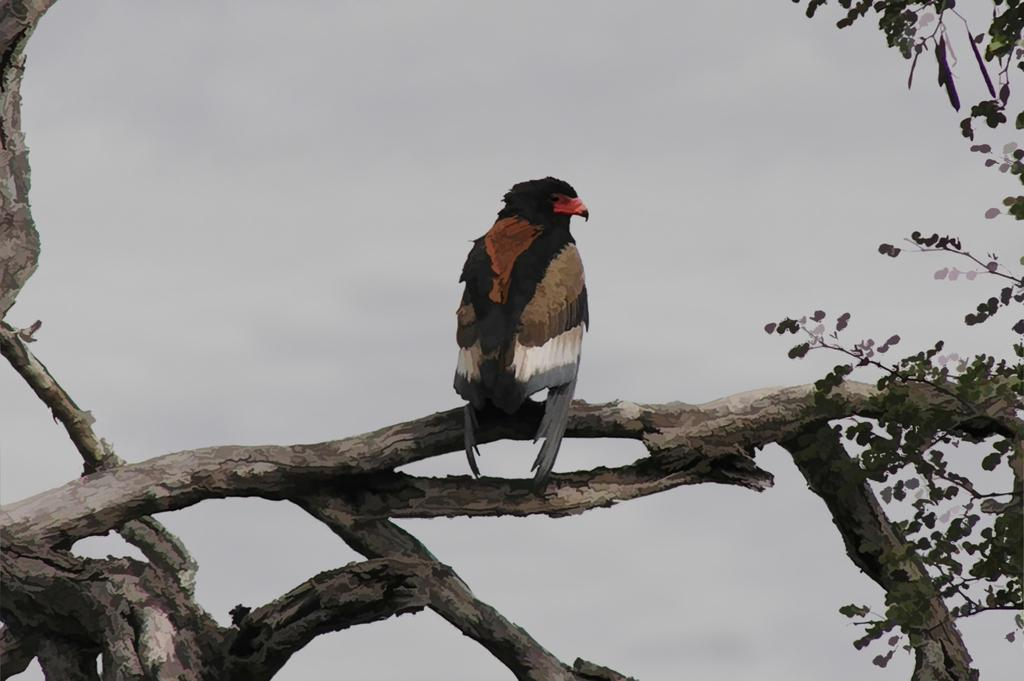What type of animal can be seen in the image? There is a bird in the image. Where is the bird located? The bird is on a branch of a tree. What else can be seen on the tree in the image? Leaves are visible in the image. What is visible in the background of the image? The sky is visible in the background of the image. What color is the van parked under the tree in the image? There is no van present in the image; it only features a bird on a tree branch with leaves and a visible sky in the background. 